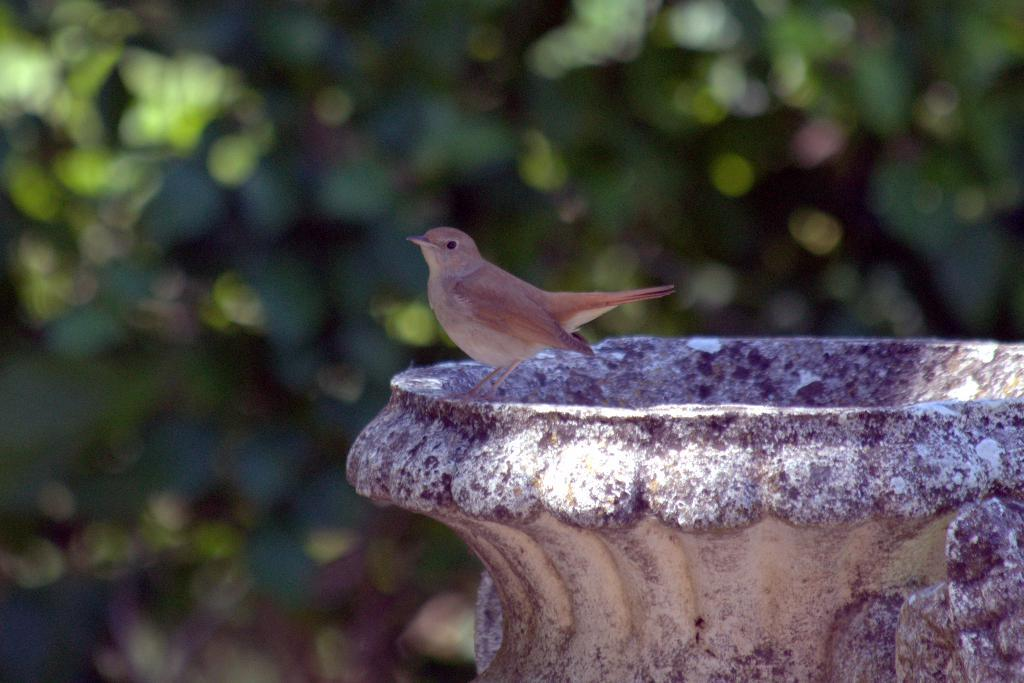What type of animal can be seen on the wall in the image? There is a bird visible on the wall in the image. What color is predominant in the background of the image? The background of the image appears to be green. How would you describe the clarity of the image? The image is blurry. Can you tell me how many memories are stored in the lake in the image? There is no lake present in the image, and therefore no memories can be stored in it. 